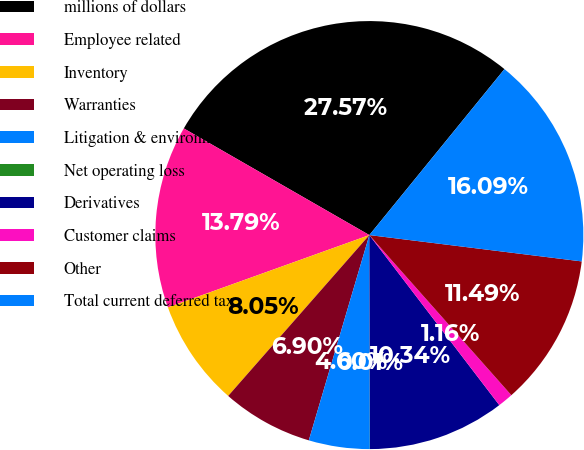Convert chart. <chart><loc_0><loc_0><loc_500><loc_500><pie_chart><fcel>millions of dollars<fcel>Employee related<fcel>Inventory<fcel>Warranties<fcel>Litigation & environmental<fcel>Net operating loss<fcel>Derivatives<fcel>Customer claims<fcel>Other<fcel>Total current deferred tax<nl><fcel>27.57%<fcel>13.79%<fcel>8.05%<fcel>6.9%<fcel>4.6%<fcel>0.01%<fcel>10.34%<fcel>1.16%<fcel>11.49%<fcel>16.09%<nl></chart> 